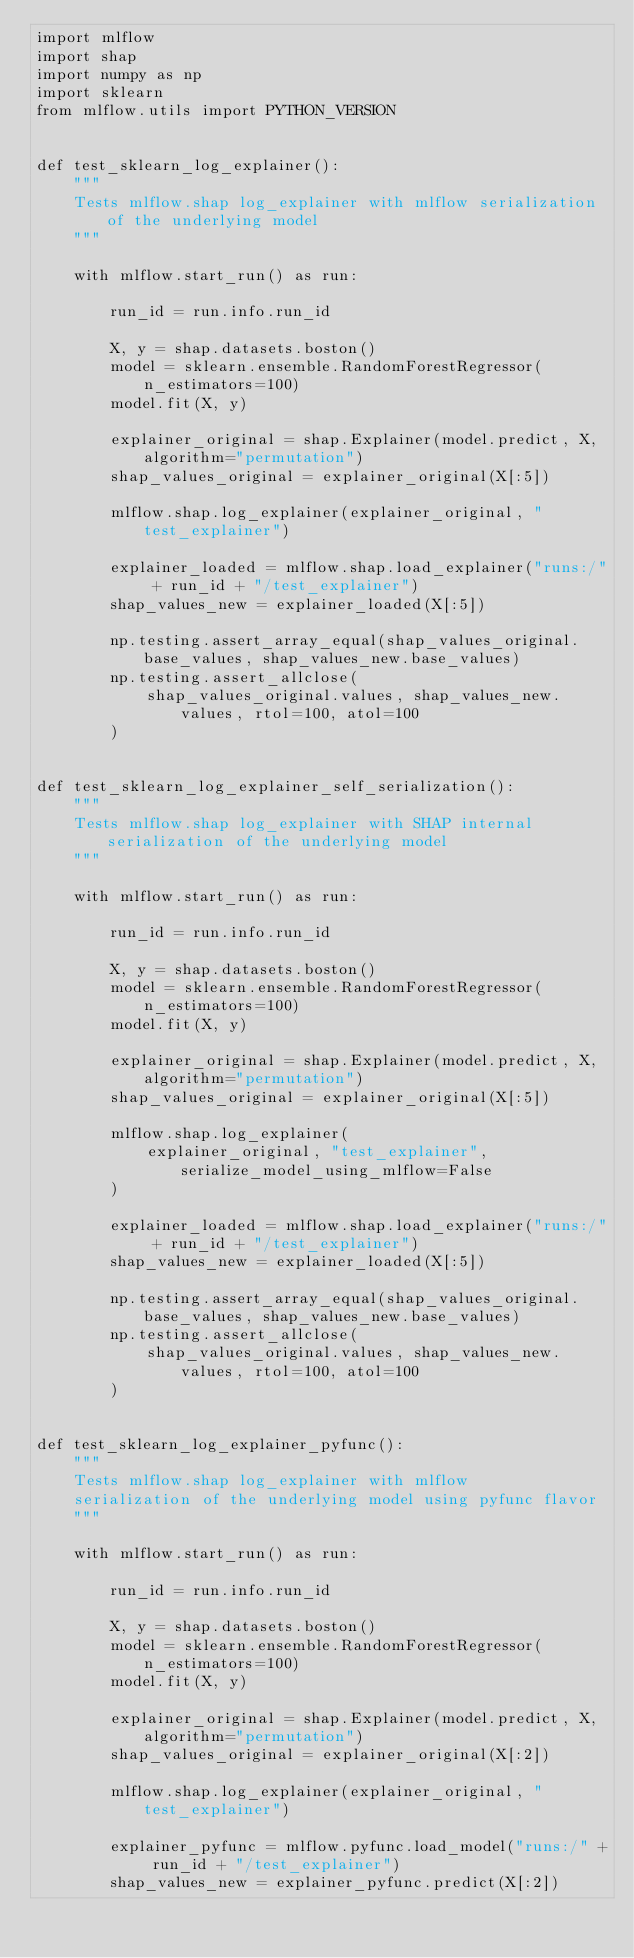Convert code to text. <code><loc_0><loc_0><loc_500><loc_500><_Python_>import mlflow
import shap
import numpy as np
import sklearn
from mlflow.utils import PYTHON_VERSION


def test_sklearn_log_explainer():
    """
    Tests mlflow.shap log_explainer with mlflow serialization of the underlying model
    """

    with mlflow.start_run() as run:

        run_id = run.info.run_id

        X, y = shap.datasets.boston()
        model = sklearn.ensemble.RandomForestRegressor(n_estimators=100)
        model.fit(X, y)

        explainer_original = shap.Explainer(model.predict, X, algorithm="permutation")
        shap_values_original = explainer_original(X[:5])

        mlflow.shap.log_explainer(explainer_original, "test_explainer")

        explainer_loaded = mlflow.shap.load_explainer("runs:/" + run_id + "/test_explainer")
        shap_values_new = explainer_loaded(X[:5])

        np.testing.assert_array_equal(shap_values_original.base_values, shap_values_new.base_values)
        np.testing.assert_allclose(
            shap_values_original.values, shap_values_new.values, rtol=100, atol=100
        )


def test_sklearn_log_explainer_self_serialization():
    """
    Tests mlflow.shap log_explainer with SHAP internal serialization of the underlying model
    """

    with mlflow.start_run() as run:

        run_id = run.info.run_id

        X, y = shap.datasets.boston()
        model = sklearn.ensemble.RandomForestRegressor(n_estimators=100)
        model.fit(X, y)

        explainer_original = shap.Explainer(model.predict, X, algorithm="permutation")
        shap_values_original = explainer_original(X[:5])

        mlflow.shap.log_explainer(
            explainer_original, "test_explainer", serialize_model_using_mlflow=False
        )

        explainer_loaded = mlflow.shap.load_explainer("runs:/" + run_id + "/test_explainer")
        shap_values_new = explainer_loaded(X[:5])

        np.testing.assert_array_equal(shap_values_original.base_values, shap_values_new.base_values)
        np.testing.assert_allclose(
            shap_values_original.values, shap_values_new.values, rtol=100, atol=100
        )


def test_sklearn_log_explainer_pyfunc():
    """
    Tests mlflow.shap log_explainer with mlflow
    serialization of the underlying model using pyfunc flavor
    """

    with mlflow.start_run() as run:

        run_id = run.info.run_id

        X, y = shap.datasets.boston()
        model = sklearn.ensemble.RandomForestRegressor(n_estimators=100)
        model.fit(X, y)

        explainer_original = shap.Explainer(model.predict, X, algorithm="permutation")
        shap_values_original = explainer_original(X[:2])

        mlflow.shap.log_explainer(explainer_original, "test_explainer")

        explainer_pyfunc = mlflow.pyfunc.load_model("runs:/" + run_id + "/test_explainer")
        shap_values_new = explainer_pyfunc.predict(X[:2])
</code> 